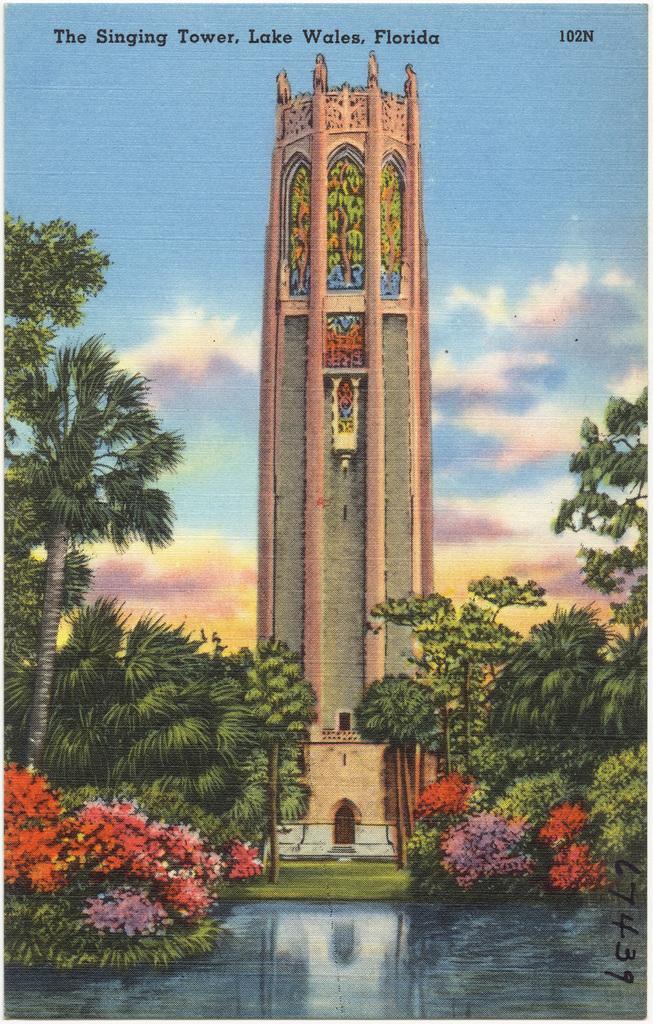Can you describe this image briefly? In this picture I can observe an art of a tower in the middle of the picture. On the either sides of the picture I can observe some plants and trees. In the background I can observe clouds in the sky. In the top of the picture I can observe some text. 